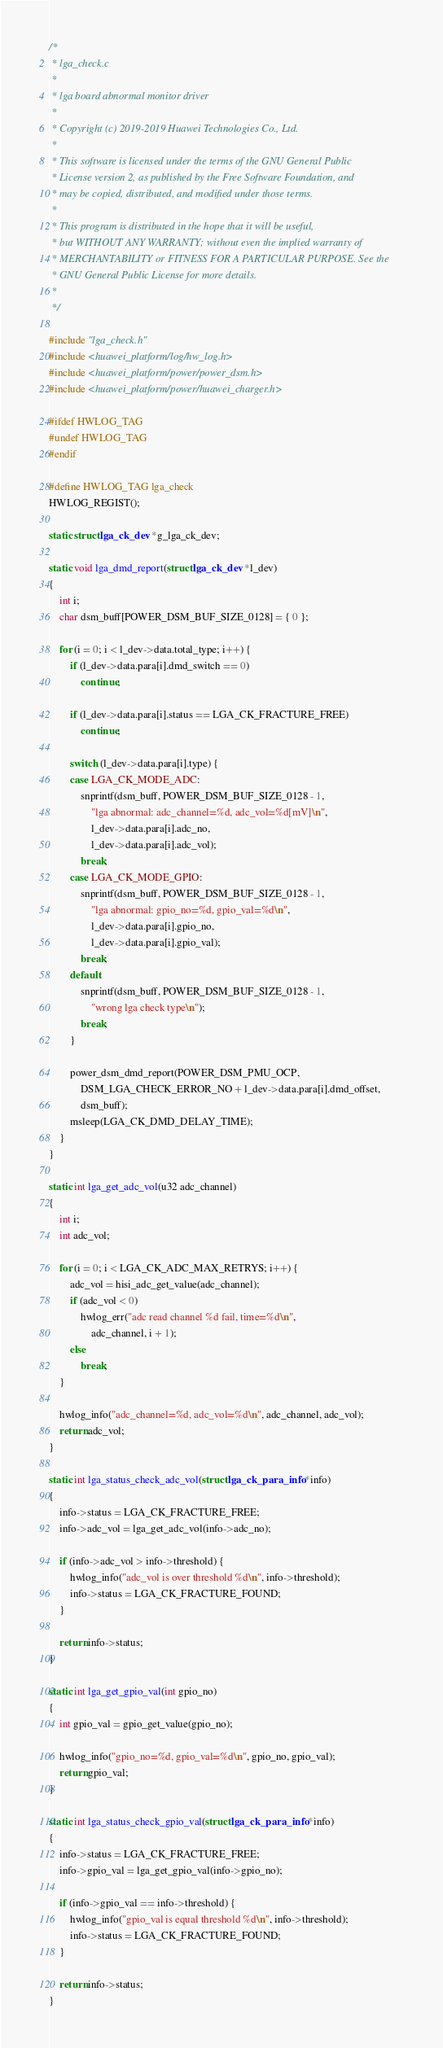Convert code to text. <code><loc_0><loc_0><loc_500><loc_500><_C_>/*
 * lga_check.c
 *
 * lga board abnormal monitor driver
 *
 * Copyright (c) 2019-2019 Huawei Technologies Co., Ltd.
 *
 * This software is licensed under the terms of the GNU General Public
 * License version 2, as published by the Free Software Foundation, and
 * may be copied, distributed, and modified under those terms.
 *
 * This program is distributed in the hope that it will be useful,
 * but WITHOUT ANY WARRANTY; without even the implied warranty of
 * MERCHANTABILITY or FITNESS FOR A PARTICULAR PURPOSE. See the
 * GNU General Public License for more details.
 *
 */

#include "lga_check.h"
#include <huawei_platform/log/hw_log.h>
#include <huawei_platform/power/power_dsm.h>
#include <huawei_platform/power/huawei_charger.h>

#ifdef HWLOG_TAG
#undef HWLOG_TAG
#endif

#define HWLOG_TAG lga_check
HWLOG_REGIST();

static struct lga_ck_dev *g_lga_ck_dev;

static void lga_dmd_report(struct lga_ck_dev *l_dev)
{
	int i;
	char dsm_buff[POWER_DSM_BUF_SIZE_0128] = { 0 };

	for (i = 0; i < l_dev->data.total_type; i++) {
		if (l_dev->data.para[i].dmd_switch == 0)
			continue;

		if (l_dev->data.para[i].status == LGA_CK_FRACTURE_FREE)
			continue;

		switch (l_dev->data.para[i].type) {
		case LGA_CK_MODE_ADC:
			snprintf(dsm_buff, POWER_DSM_BUF_SIZE_0128 - 1,
				"lga abnormal: adc_channel=%d, adc_vol=%d[mV]\n",
				l_dev->data.para[i].adc_no,
				l_dev->data.para[i].adc_vol);
			break;
		case LGA_CK_MODE_GPIO:
			snprintf(dsm_buff, POWER_DSM_BUF_SIZE_0128 - 1,
				"lga abnormal: gpio_no=%d, gpio_val=%d\n",
				l_dev->data.para[i].gpio_no,
				l_dev->data.para[i].gpio_val);
			break;
		default:
			snprintf(dsm_buff, POWER_DSM_BUF_SIZE_0128 - 1,
				"wrong lga check type\n");
			break;
		}

		power_dsm_dmd_report(POWER_DSM_PMU_OCP,
			DSM_LGA_CHECK_ERROR_NO + l_dev->data.para[i].dmd_offset,
			dsm_buff);
		msleep(LGA_CK_DMD_DELAY_TIME);
	}
}

static int lga_get_adc_vol(u32 adc_channel)
{
	int i;
	int adc_vol;

	for (i = 0; i < LGA_CK_ADC_MAX_RETRYS; i++) {
		adc_vol = hisi_adc_get_value(adc_channel);
		if (adc_vol < 0)
			hwlog_err("adc read channel %d fail, time=%d\n",
				adc_channel, i + 1);
		else
			break;
	}

	hwlog_info("adc_channel=%d, adc_vol=%d\n", adc_channel, adc_vol);
	return adc_vol;
}

static int lga_status_check_adc_vol(struct lga_ck_para_info *info)
{
	info->status = LGA_CK_FRACTURE_FREE;
	info->adc_vol = lga_get_adc_vol(info->adc_no);

	if (info->adc_vol > info->threshold) {
		hwlog_info("adc_vol is over threshold %d\n", info->threshold);
		info->status = LGA_CK_FRACTURE_FOUND;
	}

	return info->status;
}

static int lga_get_gpio_val(int gpio_no)
{
	int gpio_val = gpio_get_value(gpio_no);

	hwlog_info("gpio_no=%d, gpio_val=%d\n", gpio_no, gpio_val);
	return gpio_val;
}

static int lga_status_check_gpio_val(struct lga_ck_para_info *info)
{
	info->status = LGA_CK_FRACTURE_FREE;
	info->gpio_val = lga_get_gpio_val(info->gpio_no);

	if (info->gpio_val == info->threshold) {
		hwlog_info("gpio_val is equal threshold %d\n", info->threshold);
		info->status = LGA_CK_FRACTURE_FOUND;
	}

	return info->status;
}
</code> 